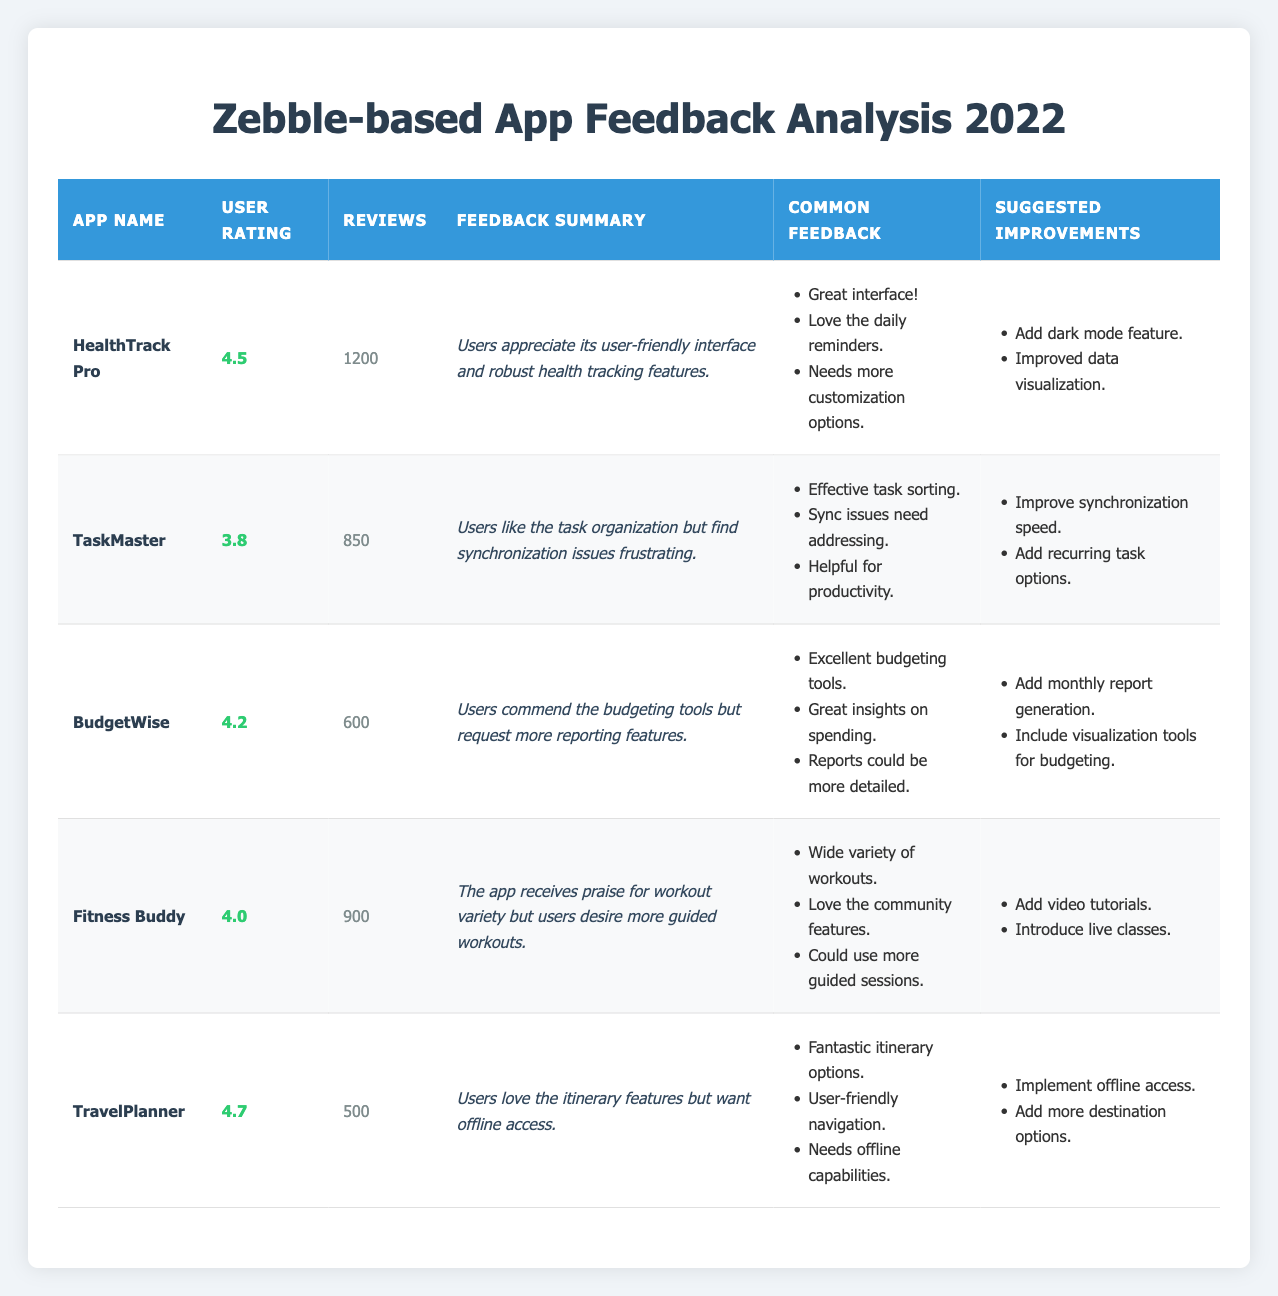What is the highest user rating among the applications listed? Looking at the table, the highest user rating is for "TravelPlanner," which has a user rating of 4.7.
Answer: 4.7 Which app has the least number of reviews? By comparing the number of reviews for each app, "TravelPlanner" has the least reviews with 500.
Answer: 500 What is the average user rating of all the apps listed? The user ratings are 4.5, 3.8, 4.2, 4.0, and 4.7. The sum is 4.5 + 3.8 + 4.2 + 4.0 + 4.7 = 21.2, and there are 5 apps, so the average rating is 21.2 / 5 = 4.24.
Answer: 4.24 Does "TaskMaster" have a user rating above 4.0? "TaskMaster" has a user rating of 3.8, which is below 4.0.
Answer: No Which app's common feedback includes the mention of "sync issues"? The common feedback for "TaskMaster" includes the mention of "Sync issues need addressing," indicating that users are experiencing synchronization problems.
Answer: TaskMaster How many reviews does "BudgetWise" have compared to "Fitness Buddy"? "BudgetWise" has 600 reviews, while "Fitness Buddy" has 900 reviews. The difference in reviews is 900 - 600 = 300.
Answer: 300 Is there any app that has a user rating of 4.0 or more and also has more than 800 reviews? Looking through the data, "HealthTrack Pro" (4.5, 1200), "BudgetWise" (4.2, 600), "Fitness Buddy" (4.0, 900), and "TravelPlanner" (4.7, 500) do fit this criterion. Therefore, "HealthTrack Pro" and "Fitness Buddy" qualify.
Answer: Yes What are the suggested improvements for "HealthTrack Pro"? The suggested improvements for "HealthTrack Pro" include adding a dark mode feature and improving data visualization.
Answer: Dark mode feature, Improved data visualization How many apps have a user rating below 4.0? "TaskMaster" (3.8) and "Fitness Buddy" (4.0) are the only apps with ratings below 4.0. Hence, 1 app has a rating below 4.0.
Answer: 1 Which app has feedback that mentions the need for offline capabilities? The feedback for "TravelPlanner" mentions the need for offline capabilities, indicating that users want access to features without an internet connection.
Answer: TravelPlanner 